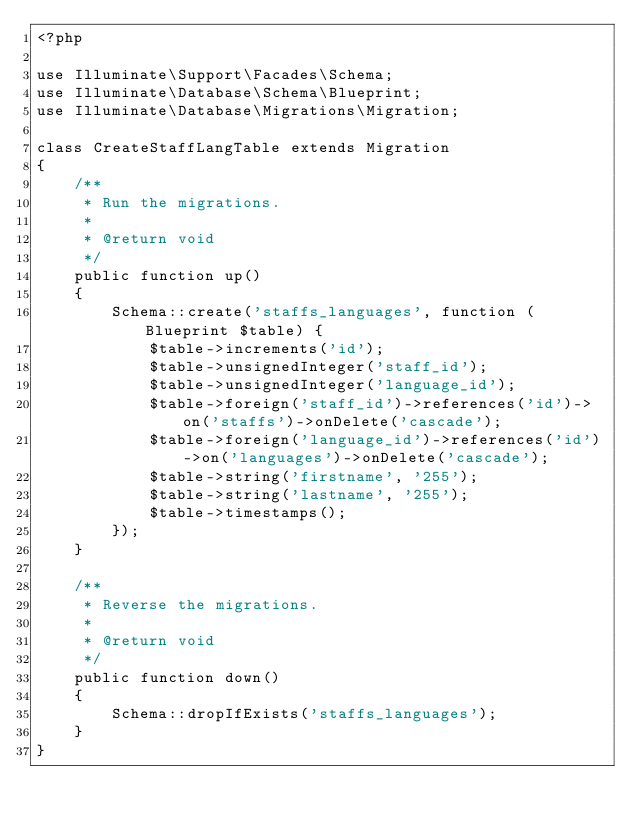Convert code to text. <code><loc_0><loc_0><loc_500><loc_500><_PHP_><?php

use Illuminate\Support\Facades\Schema;
use Illuminate\Database\Schema\Blueprint;
use Illuminate\Database\Migrations\Migration;

class CreateStaffLangTable extends Migration
{
    /**
     * Run the migrations.
     *
     * @return void
     */
    public function up()
    {
        Schema::create('staffs_languages', function (Blueprint $table) {
            $table->increments('id');
            $table->unsignedInteger('staff_id');
            $table->unsignedInteger('language_id');
            $table->foreign('staff_id')->references('id')->on('staffs')->onDelete('cascade');
            $table->foreign('language_id')->references('id')->on('languages')->onDelete('cascade');
            $table->string('firstname', '255');
            $table->string('lastname', '255');
            $table->timestamps();
        });
    }

    /**
     * Reverse the migrations.
     *
     * @return void
     */
    public function down()
    {
        Schema::dropIfExists('staffs_languages');
    }
}
</code> 